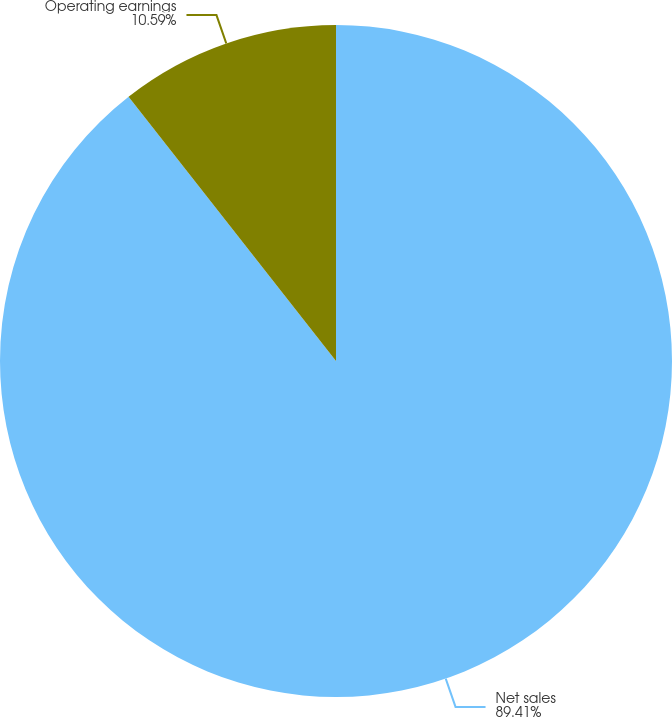<chart> <loc_0><loc_0><loc_500><loc_500><pie_chart><fcel>Net sales<fcel>Operating earnings<nl><fcel>89.41%<fcel>10.59%<nl></chart> 